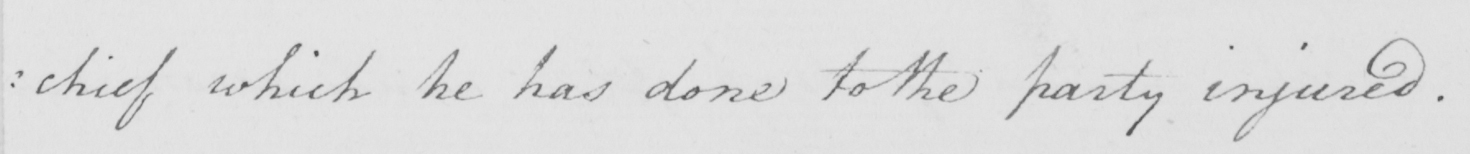Can you tell me what this handwritten text says? -chief which he has done to the party injured . 